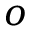<formula> <loc_0><loc_0><loc_500><loc_500>o</formula> 